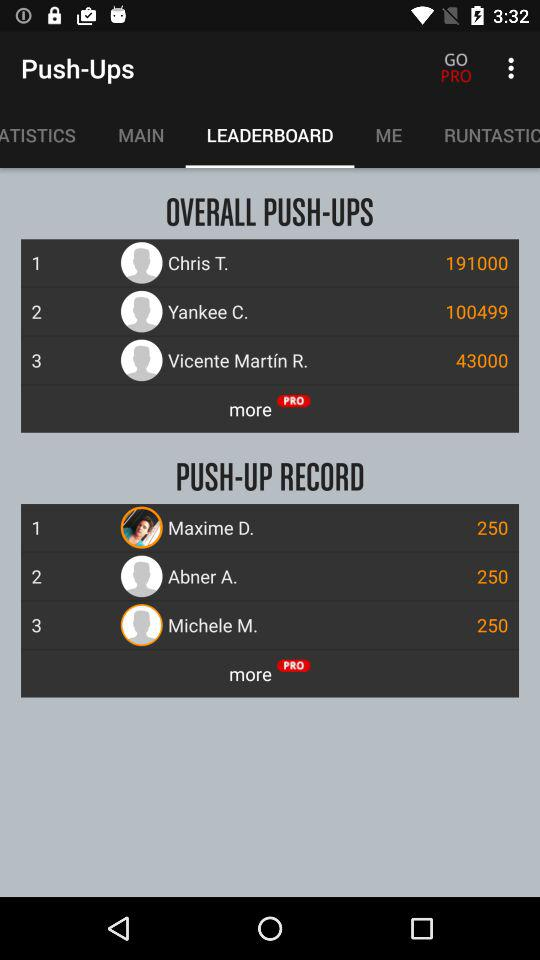Who is #4 on the leader board for overall push-ups?
When the provided information is insufficient, respond with <no answer>. <no answer> 